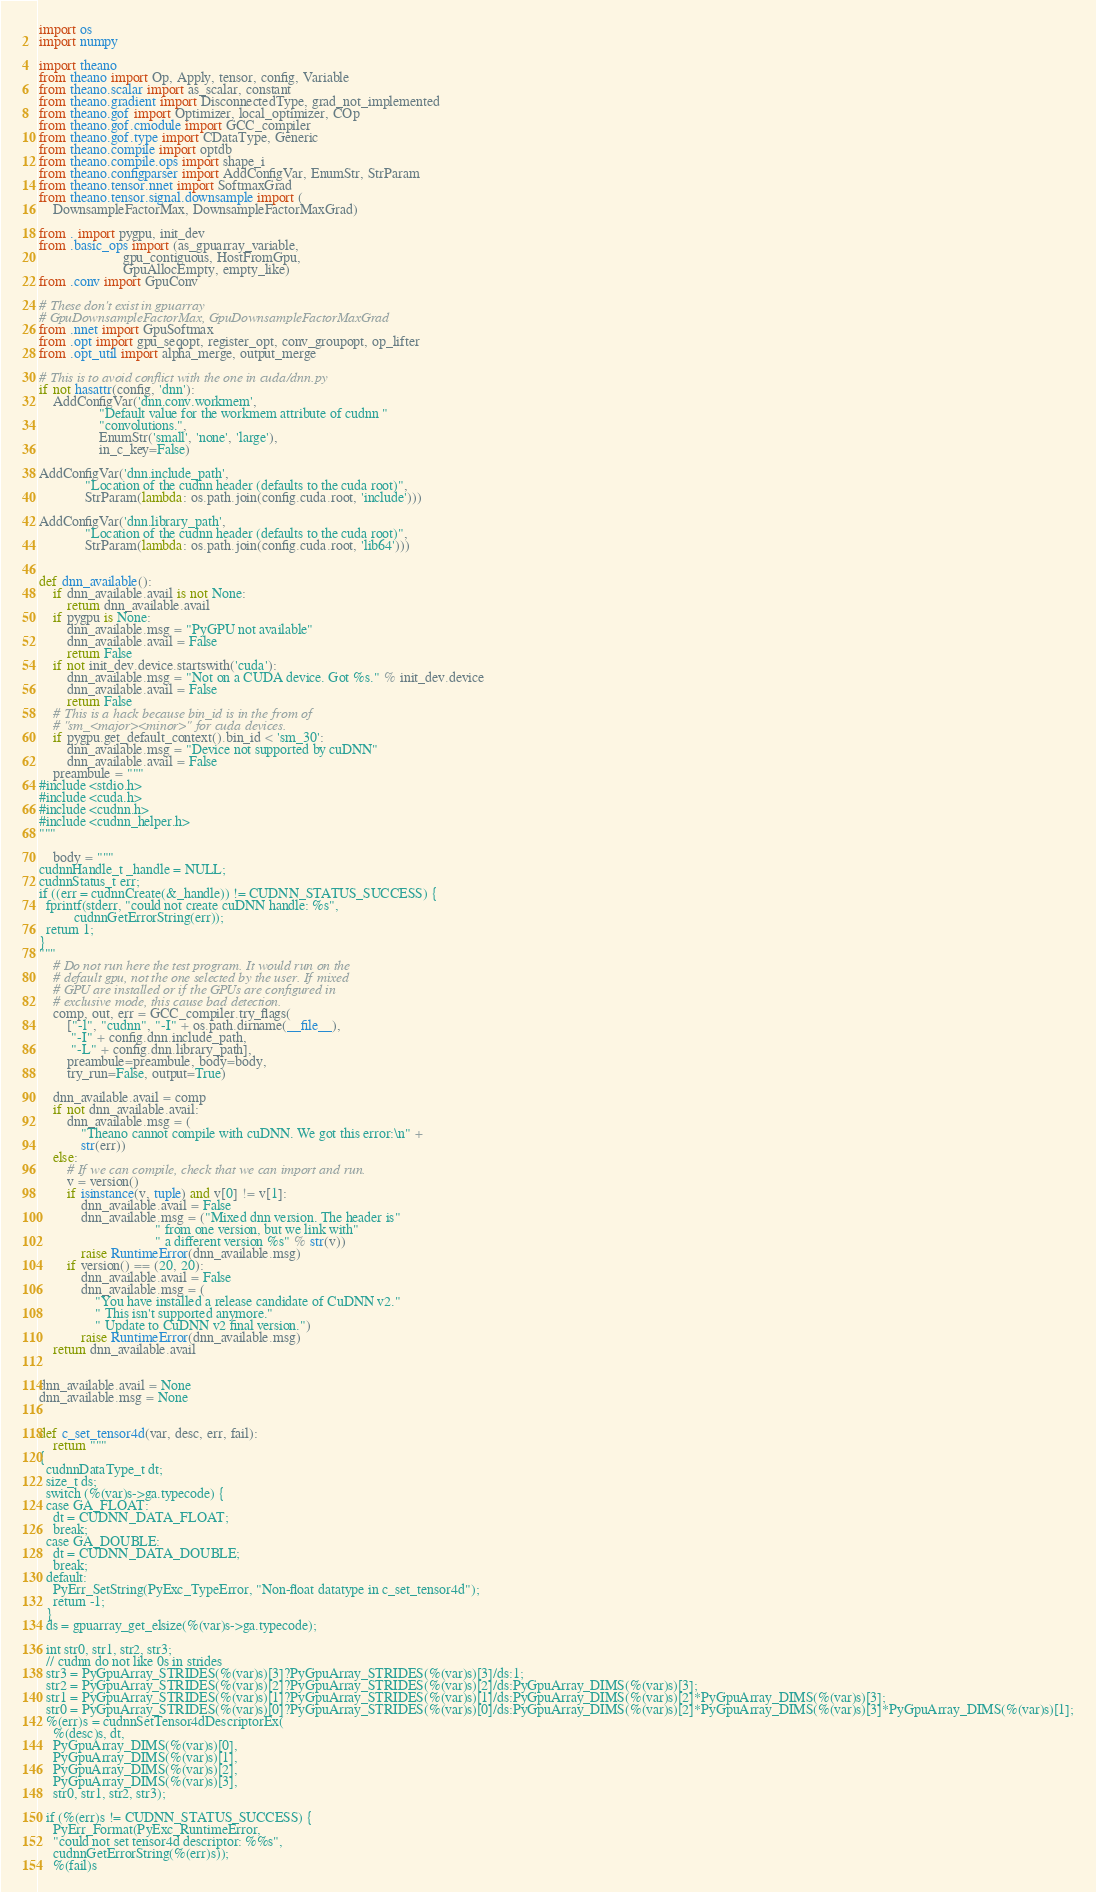Convert code to text. <code><loc_0><loc_0><loc_500><loc_500><_Python_>import os
import numpy

import theano
from theano import Op, Apply, tensor, config, Variable
from theano.scalar import as_scalar, constant
from theano.gradient import DisconnectedType, grad_not_implemented
from theano.gof import Optimizer, local_optimizer, COp
from theano.gof.cmodule import GCC_compiler
from theano.gof.type import CDataType, Generic
from theano.compile import optdb
from theano.compile.ops import shape_i
from theano.configparser import AddConfigVar, EnumStr, StrParam
from theano.tensor.nnet import SoftmaxGrad
from theano.tensor.signal.downsample import (
    DownsampleFactorMax, DownsampleFactorMaxGrad)

from . import pygpu, init_dev
from .basic_ops import (as_gpuarray_variable,
                        gpu_contiguous, HostFromGpu,
                        GpuAllocEmpty, empty_like)
from .conv import GpuConv

# These don't exist in gpuarray
# GpuDownsampleFactorMax, GpuDownsampleFactorMaxGrad
from .nnet import GpuSoftmax
from .opt import gpu_seqopt, register_opt, conv_groupopt, op_lifter
from .opt_util import alpha_merge, output_merge

# This is to avoid conflict with the one in cuda/dnn.py
if not hasattr(config, 'dnn'):
    AddConfigVar('dnn.conv.workmem',
                 "Default value for the workmem attribute of cudnn "
                 "convolutions.",
                 EnumStr('small', 'none', 'large'),
                 in_c_key=False)

AddConfigVar('dnn.include_path',
             "Location of the cudnn header (defaults to the cuda root)",
             StrParam(lambda: os.path.join(config.cuda.root, 'include')))

AddConfigVar('dnn.library_path',
             "Location of the cudnn header (defaults to the cuda root)",
             StrParam(lambda: os.path.join(config.cuda.root, 'lib64')))


def dnn_available():
    if dnn_available.avail is not None:
        return dnn_available.avail
    if pygpu is None:
        dnn_available.msg = "PyGPU not available"
        dnn_available.avail = False
        return False
    if not init_dev.device.startswith('cuda'):
        dnn_available.msg = "Not on a CUDA device. Got %s." % init_dev.device
        dnn_available.avail = False
        return False
    # This is a hack because bin_id is in the from of
    # "sm_<major><minor>" for cuda devices.
    if pygpu.get_default_context().bin_id < 'sm_30':
        dnn_available.msg = "Device not supported by cuDNN"
        dnn_available.avail = False
    preambule = """
#include <stdio.h>
#include <cuda.h>
#include <cudnn.h>
#include <cudnn_helper.h>
"""

    body = """
cudnnHandle_t _handle = NULL;
cudnnStatus_t err;
if ((err = cudnnCreate(&_handle)) != CUDNN_STATUS_SUCCESS) {
  fprintf(stderr, "could not create cuDNN handle: %s",
          cudnnGetErrorString(err));
  return 1;
}
"""
    # Do not run here the test program. It would run on the
    # default gpu, not the one selected by the user. If mixed
    # GPU are installed or if the GPUs are configured in
    # exclusive mode, this cause bad detection.
    comp, out, err = GCC_compiler.try_flags(
        ["-l", "cudnn", "-I" + os.path.dirname(__file__),
         "-I" + config.dnn.include_path,
         "-L" + config.dnn.library_path],
        preambule=preambule, body=body,
        try_run=False, output=True)

    dnn_available.avail = comp
    if not dnn_available.avail:
        dnn_available.msg = (
            "Theano cannot compile with cuDNN. We got this error:\n" +
            str(err))
    else:
        # If we can compile, check that we can import and run.
        v = version()
        if isinstance(v, tuple) and v[0] != v[1]:
            dnn_available.avail = False
            dnn_available.msg = ("Mixed dnn version. The header is"
                                 " from one version, but we link with"
                                 " a different version %s" % str(v))
            raise RuntimeError(dnn_available.msg)
        if version() == (20, 20):
            dnn_available.avail = False
            dnn_available.msg = (
                "You have installed a release candidate of CuDNN v2."
                " This isn't supported anymore."
                " Update to CuDNN v2 final version.")
            raise RuntimeError(dnn_available.msg)
    return dnn_available.avail


dnn_available.avail = None
dnn_available.msg = None


def c_set_tensor4d(var, desc, err, fail):
    return """
{
  cudnnDataType_t dt;
  size_t ds;
  switch (%(var)s->ga.typecode) {
  case GA_FLOAT:
    dt = CUDNN_DATA_FLOAT;
    break;
  case GA_DOUBLE:
    dt = CUDNN_DATA_DOUBLE;
    break;
  default:
    PyErr_SetString(PyExc_TypeError, "Non-float datatype in c_set_tensor4d");
    return -1;
  }
  ds = gpuarray_get_elsize(%(var)s->ga.typecode);

  int str0, str1, str2, str3;
  // cudnn do not like 0s in strides
  str3 = PyGpuArray_STRIDES(%(var)s)[3]?PyGpuArray_STRIDES(%(var)s)[3]/ds:1;
  str2 = PyGpuArray_STRIDES(%(var)s)[2]?PyGpuArray_STRIDES(%(var)s)[2]/ds:PyGpuArray_DIMS(%(var)s)[3];
  str1 = PyGpuArray_STRIDES(%(var)s)[1]?PyGpuArray_STRIDES(%(var)s)[1]/ds:PyGpuArray_DIMS(%(var)s)[2]*PyGpuArray_DIMS(%(var)s)[3];
  str0 = PyGpuArray_STRIDES(%(var)s)[0]?PyGpuArray_STRIDES(%(var)s)[0]/ds:PyGpuArray_DIMS(%(var)s)[2]*PyGpuArray_DIMS(%(var)s)[3]*PyGpuArray_DIMS(%(var)s)[1];
  %(err)s = cudnnSetTensor4dDescriptorEx(
    %(desc)s, dt,
    PyGpuArray_DIMS(%(var)s)[0],
    PyGpuArray_DIMS(%(var)s)[1],
    PyGpuArray_DIMS(%(var)s)[2],
    PyGpuArray_DIMS(%(var)s)[3],
    str0, str1, str2, str3);

  if (%(err)s != CUDNN_STATUS_SUCCESS) {
    PyErr_Format(PyExc_RuntimeError,
    "could not set tensor4d descriptor: %%s",
    cudnnGetErrorString(%(err)s));
    %(fail)s</code> 